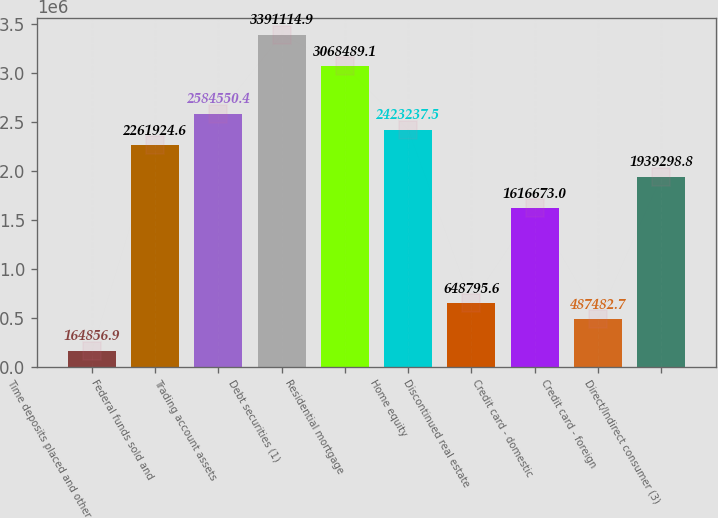<chart> <loc_0><loc_0><loc_500><loc_500><bar_chart><fcel>Time deposits placed and other<fcel>Federal funds sold and<fcel>Trading account assets<fcel>Debt securities (1)<fcel>Residential mortgage<fcel>Home equity<fcel>Discontinued real estate<fcel>Credit card - domestic<fcel>Credit card - foreign<fcel>Direct/Indirect consumer (3)<nl><fcel>164857<fcel>2.26192e+06<fcel>2.58455e+06<fcel>3.39111e+06<fcel>3.06849e+06<fcel>2.42324e+06<fcel>648796<fcel>1.61667e+06<fcel>487483<fcel>1.9393e+06<nl></chart> 